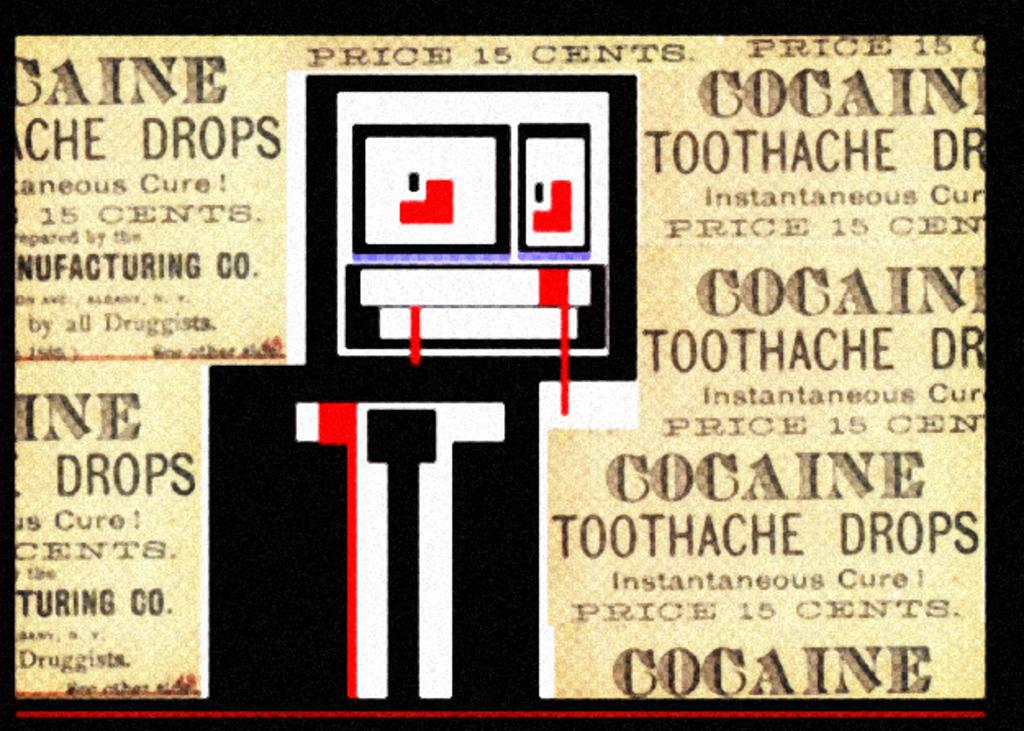<image>
Summarize the visual content of the image. An advertisement for cocaine toothache drops shows the price of 15 cents. 